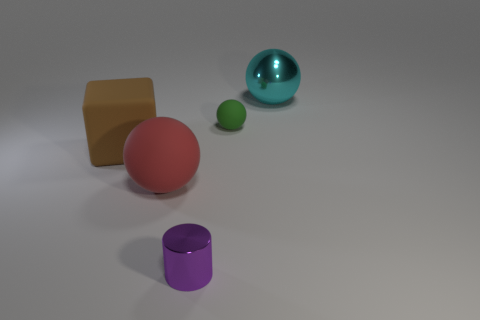What shape is the metal object in front of the cyan shiny sphere? cylinder 